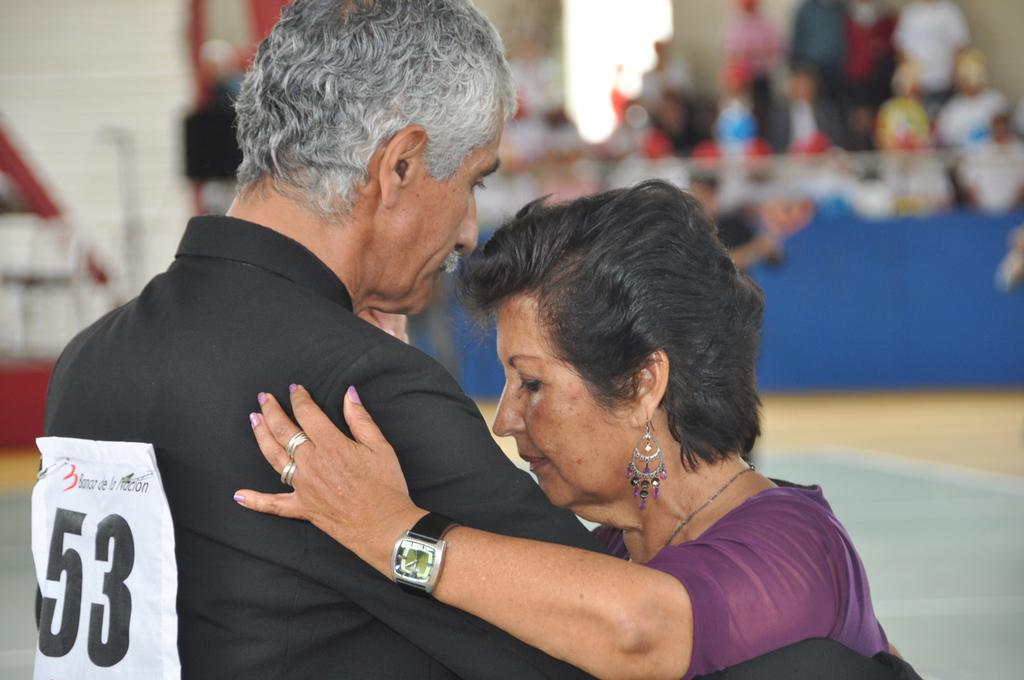<image>
Offer a succinct explanation of the picture presented. A man with the number 53 on his back dancing with a woman. 